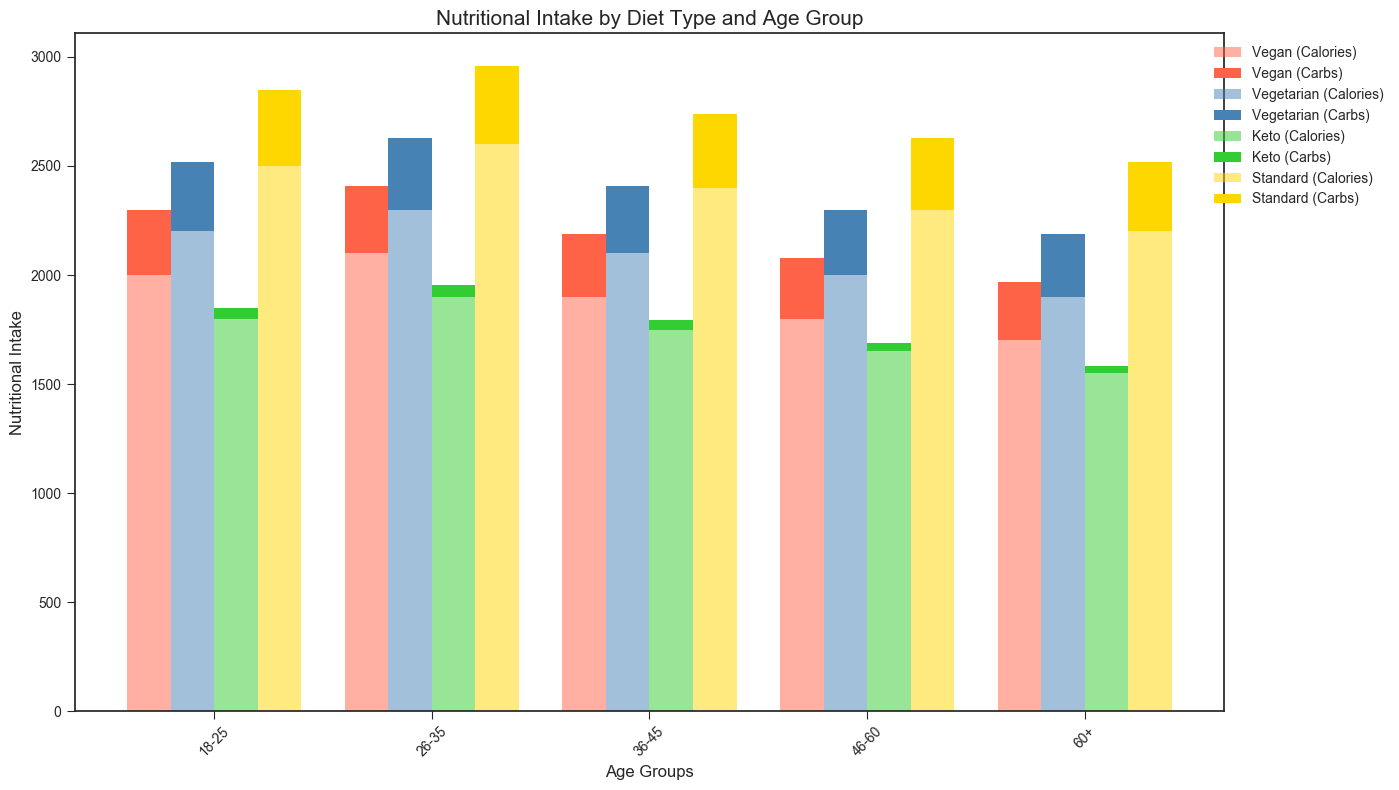Which diet type has the highest calorie intake for the 26-35 age group? By looking at the bars corresponding to the 26-35 age group, we can compare the height of each. The Standard diet type has the highest bar for calories.
Answer: Standard What's the total carb intake for Vegan and Vegetarian diets in the 18-25 age group? Add the carb intake for both Vegan and Vegetarian diets in the 18-25 age group: Vegan (300) + Vegetarian (320) = 620.
Answer: 620 Which age group consumes the least amount of fat in the Keto diet? By comparing the height of the bars for each age group for the Keto diet, we see that the 60+ age group has the shortest bar for fat.
Answer: 60+ How does the protein intake of the Vegan diet in the 36-45 age group compare to that of the Keto diet in the same age group? Compare the height of the protein bars for the Vegan and Keto diets in the 36-45 age group. The Vegan diet has a shorter bar (48) compared to Keto (115).
Answer: Keto is higher What's the difference in calorie intake between the Keto and Standard diets for people aged 46-60? Subtract the calorie intake of Keto (1650) from Standard (2300) for the 46-60 age group: 2300 - 1650 = 650.
Answer: 650 Which diet has the highest carb intake across all age groups? By comparing the height of the carb bars for all diets across all age groups, we see that the Standard diet has the tallest bars overall.
Answer: Standard Which diet type shows a consistent decrease in calorie intake as age increases? By examining the height of the calorie bars for each diet type across different age groups, we can see that the Keto diet consistently decreases in calories from age group 18-25 to 60+.
Answer: Keto Calculate the average fat intake for the Vegetarian diet across all age groups. Add the fat intake of the Vegetarian diet across all age groups: 70 + 75 + 68 + 65 + 60 = 338. Divide by the number of age groups (5): 338 / 5 = 67.6.
Answer: 67.6 